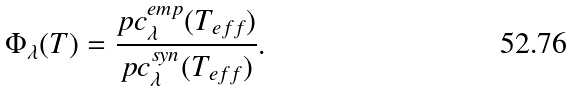<formula> <loc_0><loc_0><loc_500><loc_500>\Phi _ { \lambda } ( T ) = \frac { p c _ { \lambda } ^ { e m p } ( T _ { e f f } ) } { p c _ { \lambda } ^ { s y n } ( T _ { e f f } ) } .</formula> 